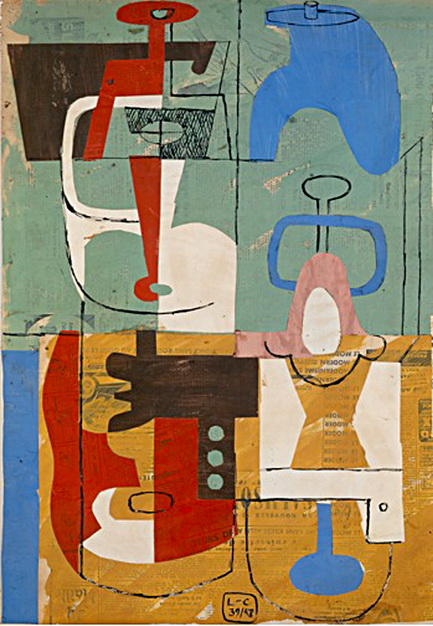How does the composition of the artwork interact with its theme? The composition of this artwork, with its distinct sections and integration of different geometric shapes and colors, creates a visual dialogue between order and chaos. This could reflect the theme of the modern existential condition, highlighting tension and fragmentation yet also suggesting a harmonious interconnection within diversity. Each element, while seemingly isolated, contributes to a cohesive whole, mirroring how diverse experiences and perspectives can form a unified yet complex narrative.  Could you please explore the significance of the textural background in this painting? The textured background serves both aesthetic and thematic functions. Aesthetically, it adds depth and contrast, helping the brighter and more vivid shapes in the foreground stand out. Thematically, the subtler, softer background might symbolize the underlying realities or emotions that are overshadowed by more immediate, striking experiences. This contrast between foreground and background could be seen as a commentary on how underlying truths are often overlooked in our perception of reality. 